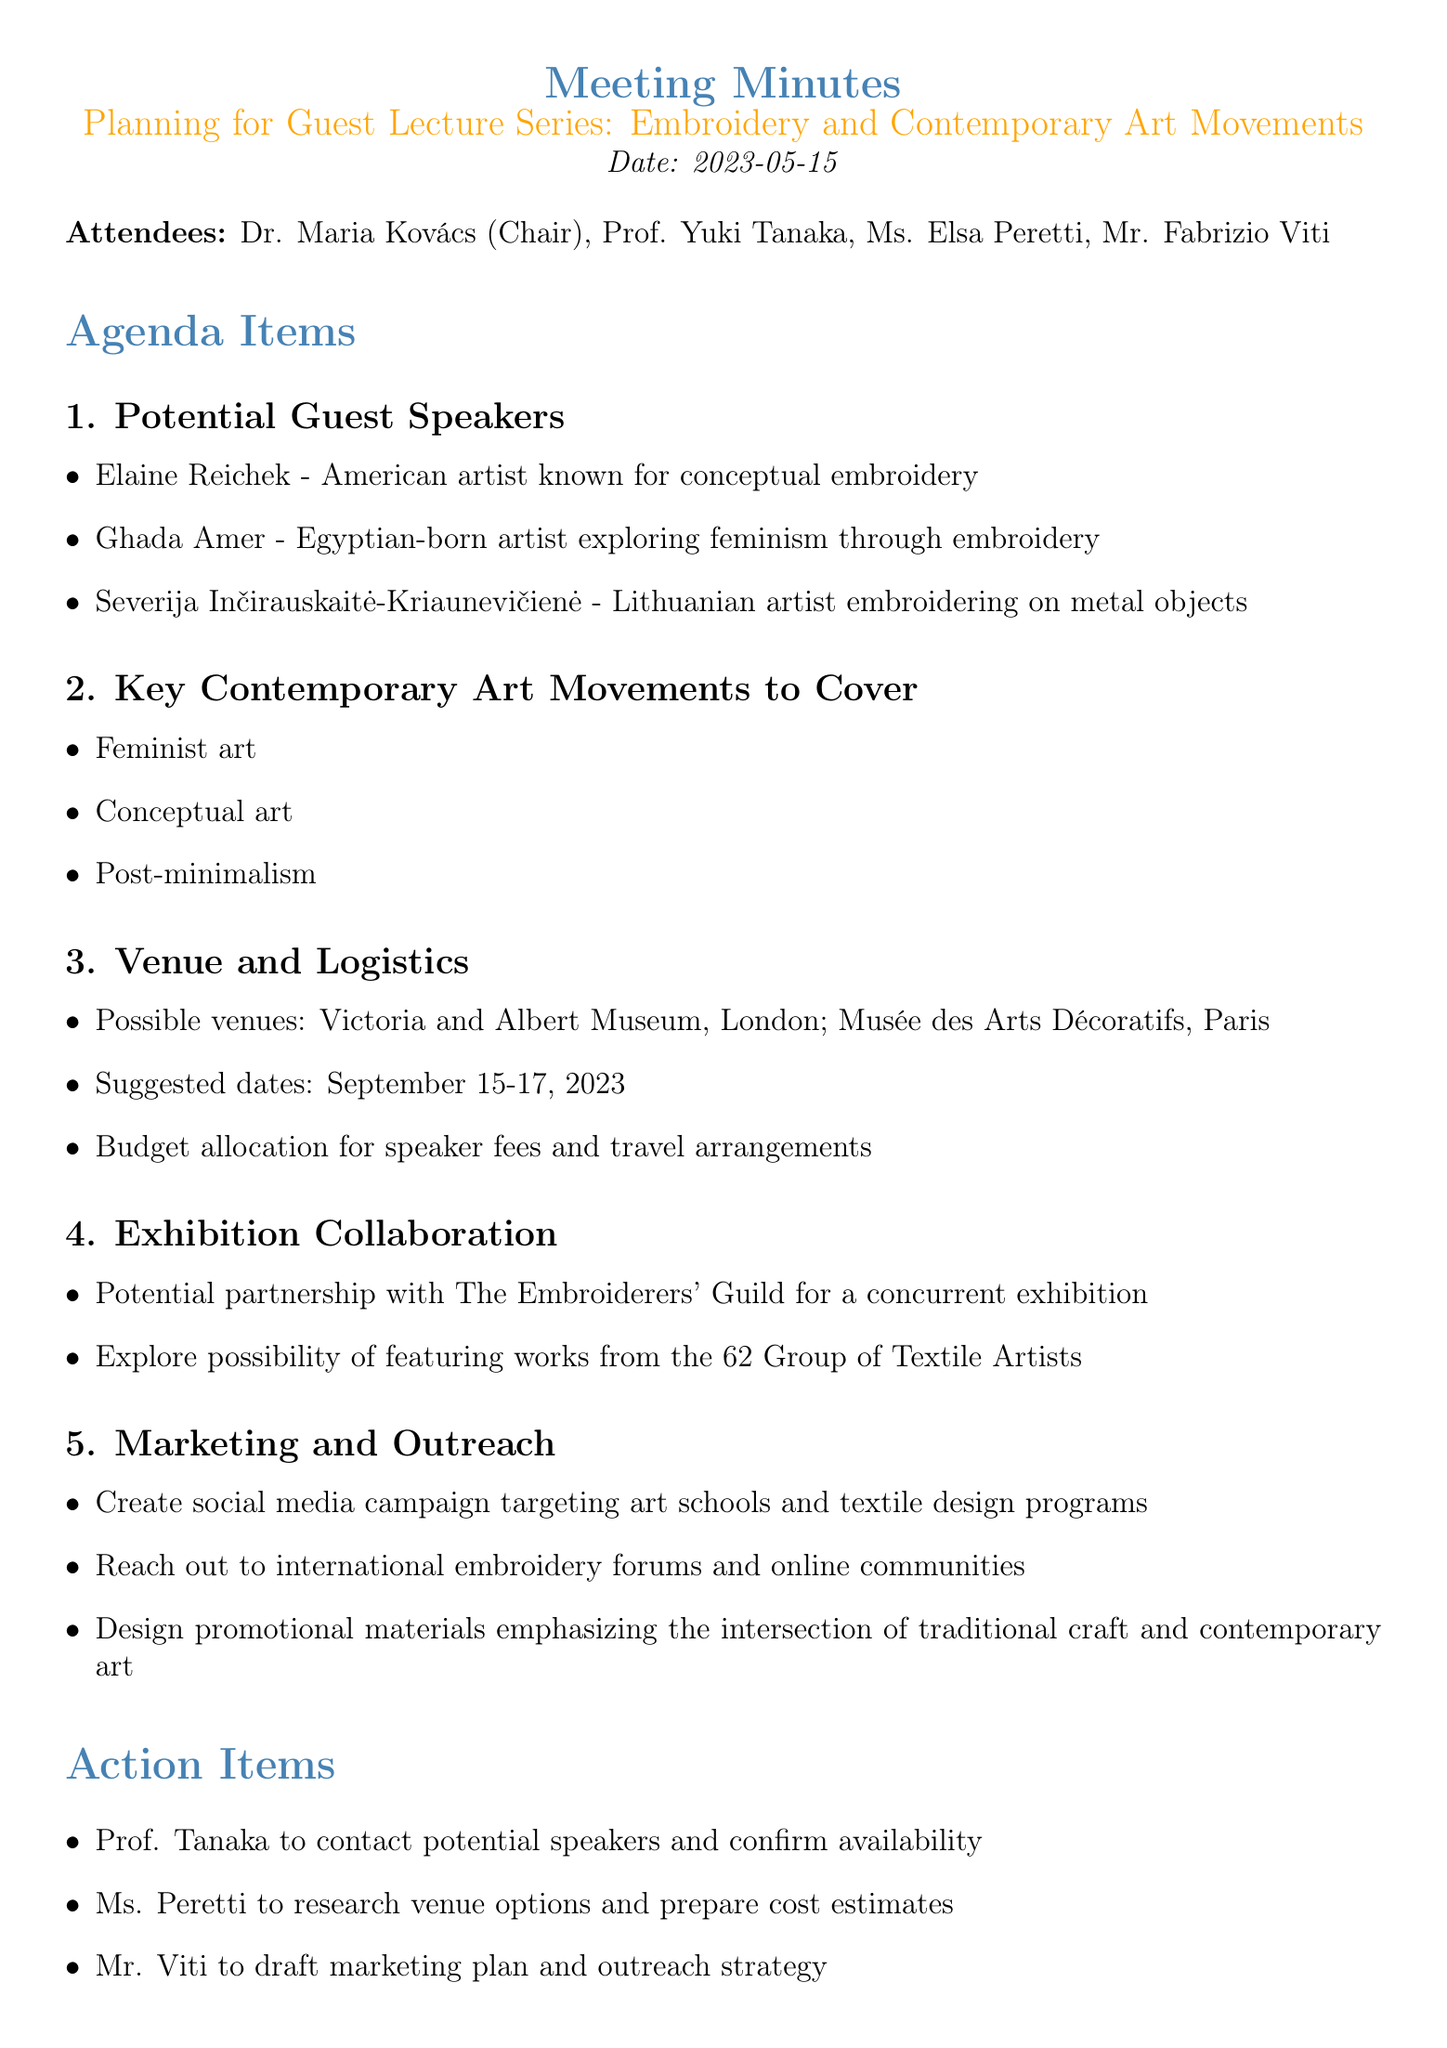What is the date of the meeting? The date of the meeting is specified in the document as the date when the planning took place.
Answer: 2023-05-15 Who is the chair of the meeting? The document states the attendees and identifies Dr. Maria Kovács as the chair of the meeting.
Answer: Dr. Maria Kovács What are the possible venues for the lecture series? The meeting minutes mention specific venues being considered for the event.
Answer: Victoria and Albert Museum, Musée des Arts Décoratifs What are the suggested dates for the lecture series? The suggested dates are provided in the logistics section of the agenda.
Answer: September 15-17, 2023 Who is responsible for contacting the potential speakers? The action items list assigns a specific attendee to this responsibility.
Answer: Prof. Tanaka What key contemporary art movement focuses on social issues? The agenda covers movements that include responses to social contexts; one of the movements listed is focused on such themes.
Answer: Feminist art How many attendees were present at the meeting? The document lists the names of attendees, allowing us to count how many were present.
Answer: Four What is the purpose of the marketing campaign mentioned in the document? The marketing strategies outlined in the document aim to target specific groups for promotion.
Answer: Targeting art schools and textile design programs What collaboration is sought in the exhibition section? The document discusses a potential partnership involving a specific organization known for its focus on embroidery.
Answer: The Embroiderers' Guild 